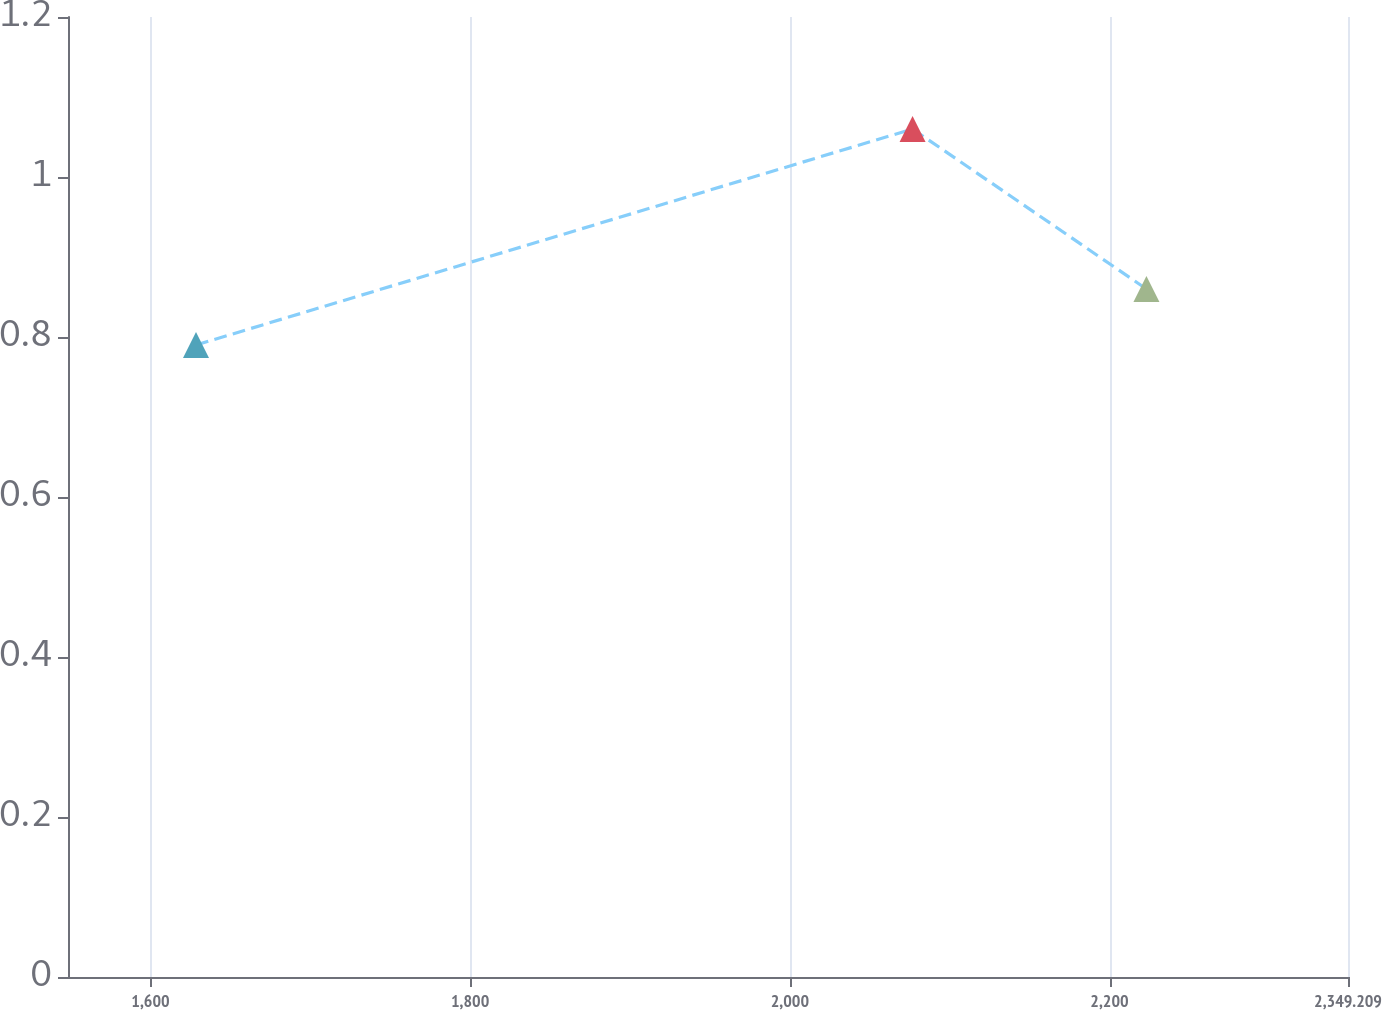<chart> <loc_0><loc_0><loc_500><loc_500><line_chart><ecel><fcel>Unnamed: 1<nl><fcel>1628.48<fcel>0.79<nl><fcel>2076.78<fcel>1.06<nl><fcel>2223.11<fcel>0.86<nl><fcel>2354.82<fcel>0.96<nl><fcel>2429.29<fcel>0.82<nl></chart> 